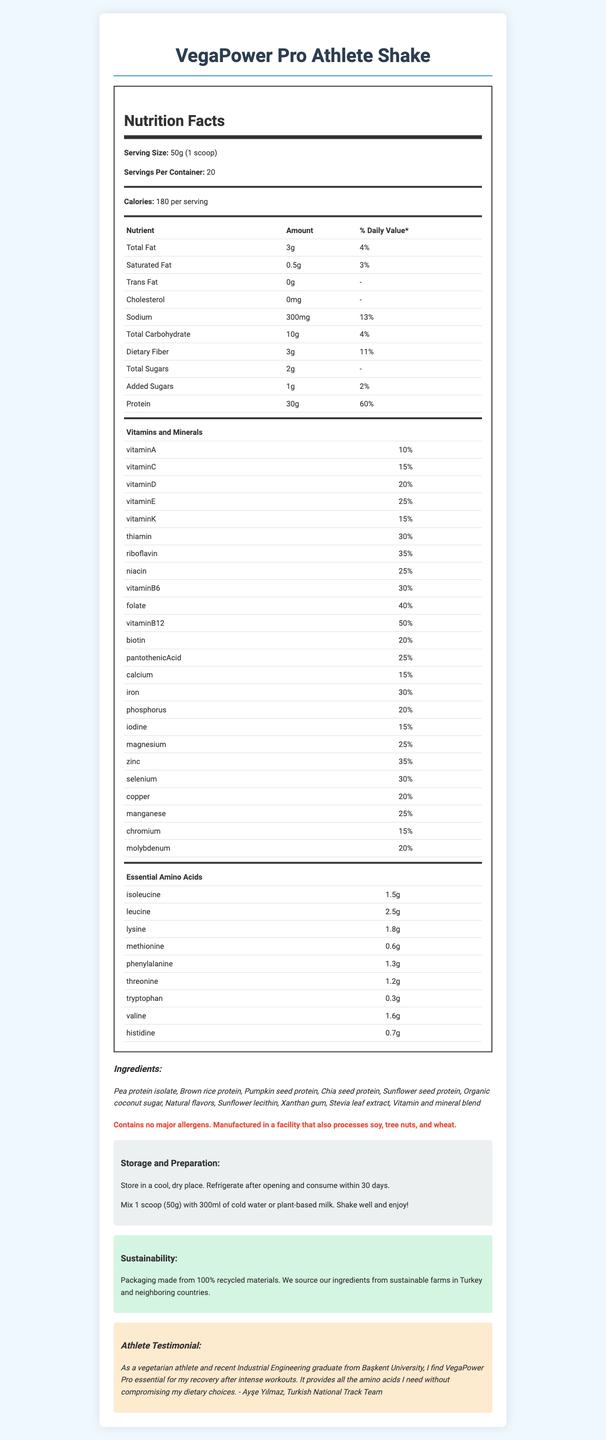what is the serving size? The serving size is explicitly mentioned as "50g (1 scoop)".
Answer: 50g (1 scoop) how many calories are in one serving? The nutrition label shows that there are 180 calories per serving.
Answer: 180 what is the protein content per serving? The amount of protein per serving is listed as 30g.
Answer: 30g how much dietary fiber is in each serving and what is its daily value percentage? The document states that there are 3g of dietary fiber in each serving which is 11% of the daily value.
Answer: 3g, 11% how much sodium is present per serving? The sodium content per serving is 300mg.
Answer: 300mg which vitamin has the highest daily value percentage? A. Vitamin A B. Vitamin B12 C. Calcium D. Vitamin C According to the label, Vitamin B12 has the highest daily value percentage at 50%.
Answer: B. Vitamin B12 what is the main carbohydrate source in the product? The list of ingredients identifies brown rice protein as one of the primary sources, along with other proteins.
Answer: Brown rice protein is this product suitable for someone who is lactose intolerant? The product contains no dairy ingredients and is plant-based, making it suitable for someone who is lactose intolerant.
Answer: Yes how many servings are in a container? The document states there are 20 servings per container.
Answer: 20 what is the recommended preparation for the shake? The preparation instructions are clearly provided in the document.
Answer: Mix 1 scoop (50g) with 300ml of cold water or plant-based milk. Shake well and enjoy! which amino acid is present in the highest amount? Leucine has the highest amount with 2.5g per serving as listed in the amino acid profile.
Answer: Leucine does this product contain any added sugars? The nutrition label indicates that the product contains 1g of added sugars per serving.
Answer: Yes what is the sustainability aspect of the packaging? The sustainability section mentions that the packaging is made from 100% recycled materials.
Answer: Packaging made from 100% recycled materials. which of the following is NOT an ingredient in this product? A. Pea protein isolate B. Soy protein C. Stevia leaf extract D. Sunflower lecithin According to the ingredient list, soy protein is not used, but pea protein isolate, stevia leaf extract, and sunflower lecithin are.
Answer: B. Soy protein is this product free from allergens? While the product itself does not contain major allergens, it is manufactured in a facility that processes soy, tree nuts, and wheat.
Answer: Contains no major allergens. Manufactured in a facility that also processes soy, tree nuts, and wheat. how should the product be stored after opening? The storage instructions specify refrigeration after opening and consumption within 30 days.
Answer: Refrigerate after opening and consume within 30 days. describe the overall content and purpose of this document. The document aims to provide detailed nutritional information and usage instructions for a plant-based protein shake targeted at vegetarian athletes.
Answer: The document is a comprehensive nutrition facts label for VegaPower Pro Athlete Shake. It includes details on serving size, macronutrient breakdown, vitamins and minerals, amino acid profile, ingredients, allergen information, storage and preparation instructions, sustainability practices, and a testimonial from a vegetarian athlete. what is Ayşe Yılmaz's relationship to this product? The document provides a testimonial from Ayşe Yılmaz but does not elaborate on her relationship to the product beyond being an athlete and a user of the product.
Answer: I don't know 